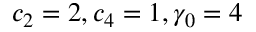Convert formula to latex. <formula><loc_0><loc_0><loc_500><loc_500>c _ { 2 } = 2 , c _ { 4 } = 1 , \gamma _ { 0 } = 4</formula> 